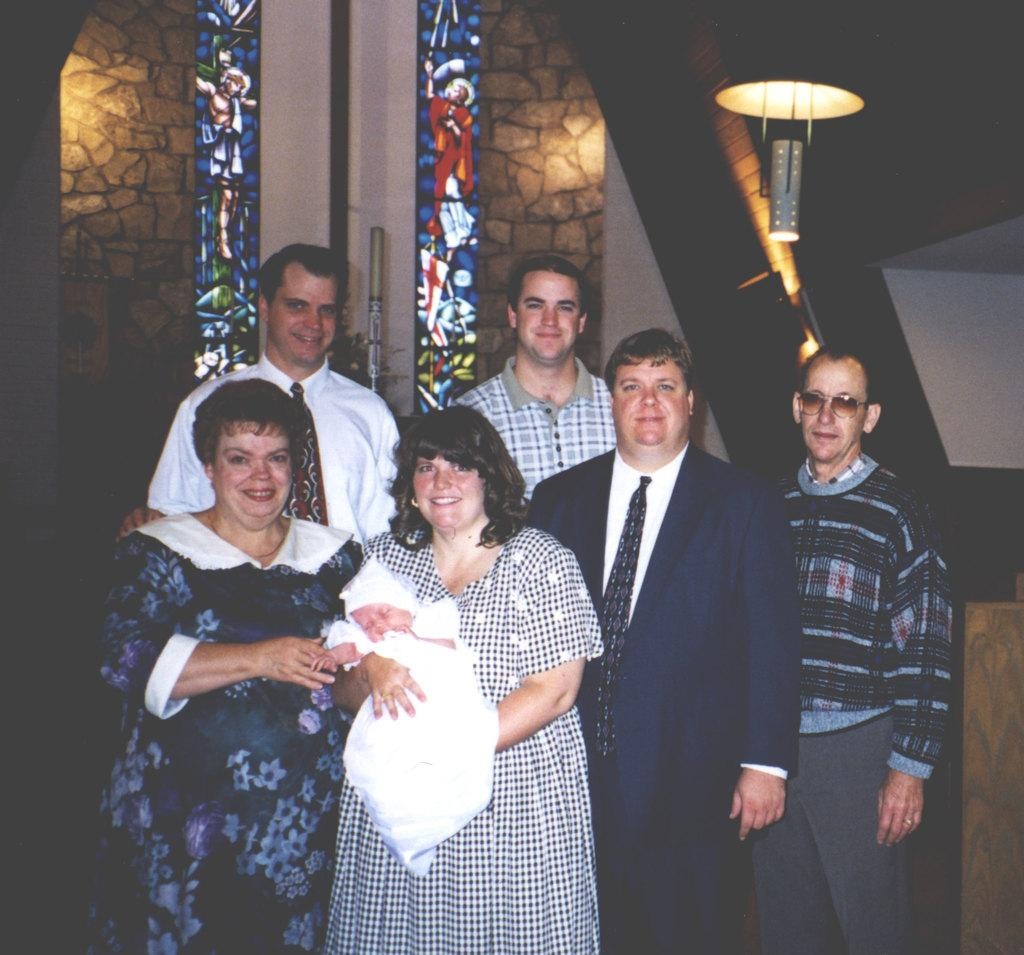How many people are in the image? There are people in the image, but the exact number is not specified. What is the woman in the image doing? The woman is holding a baby in the image. Can you describe the lighting in the image? There is light in the image, but the source or intensity of the light is not specified. What type of locket is the baby wearing in the image? There is no mention of a locket in the image, so it cannot be determined if the baby is wearing one. How many breaths can be heard from the people in the image? The image is a still picture, so it is not possible to hear any breaths from the people in the image. 